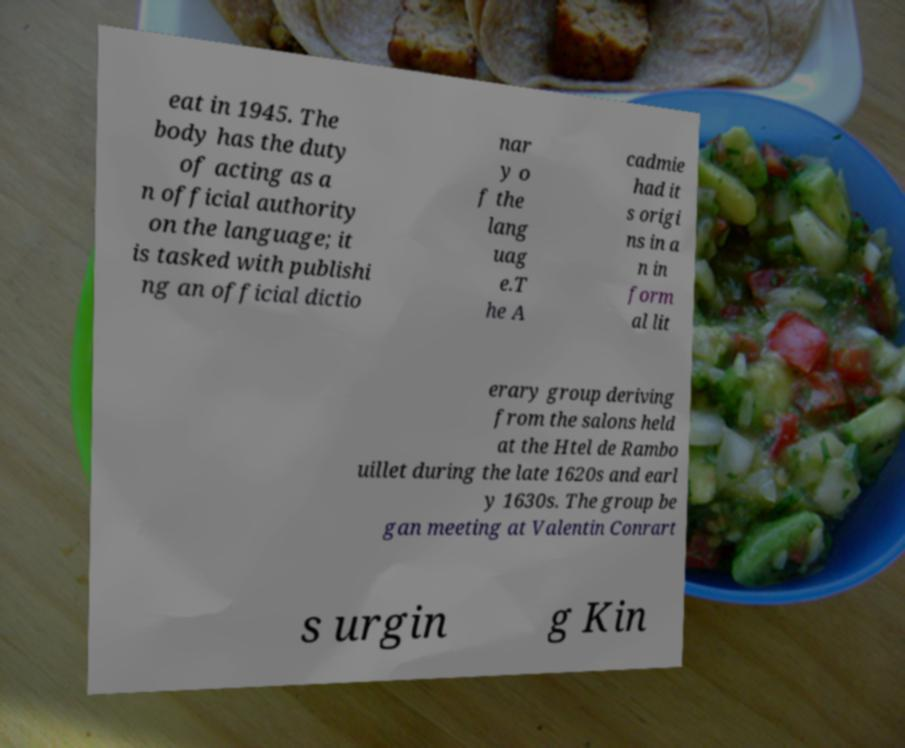I need the written content from this picture converted into text. Can you do that? eat in 1945. The body has the duty of acting as a n official authority on the language; it is tasked with publishi ng an official dictio nar y o f the lang uag e.T he A cadmie had it s origi ns in a n in form al lit erary group deriving from the salons held at the Htel de Rambo uillet during the late 1620s and earl y 1630s. The group be gan meeting at Valentin Conrart s urgin g Kin 